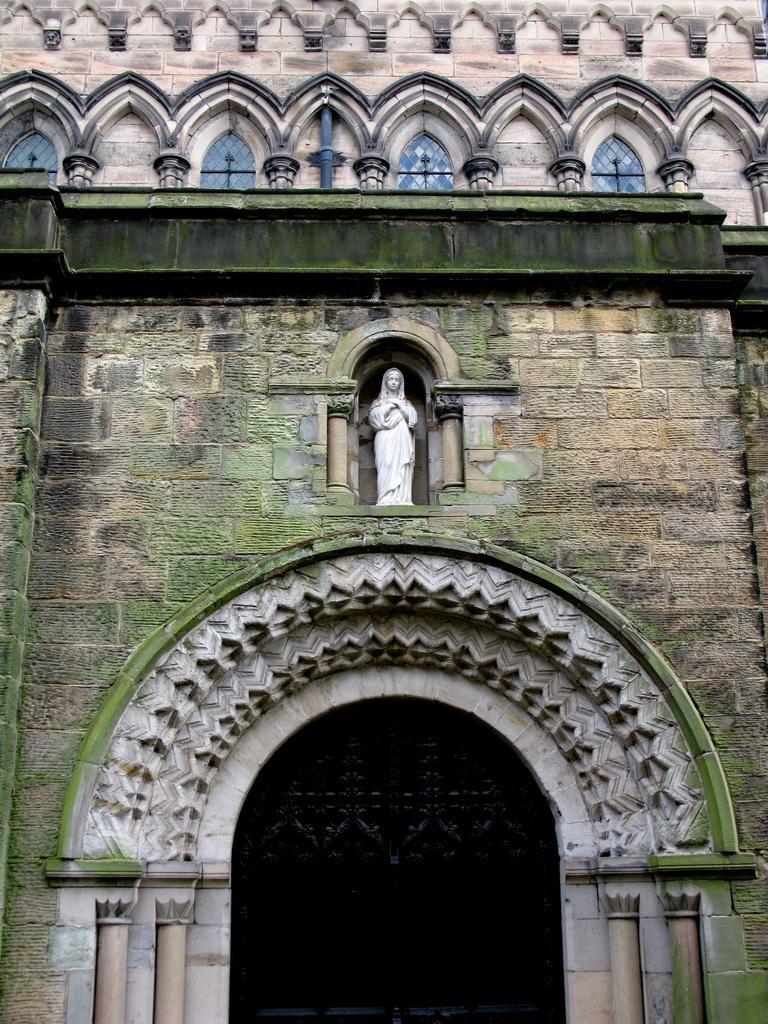How would you summarize this image in a sentence or two? In this picture we can see a building. On this building we can see an arch. There is a statue and a few lanterns are visible on this building. 